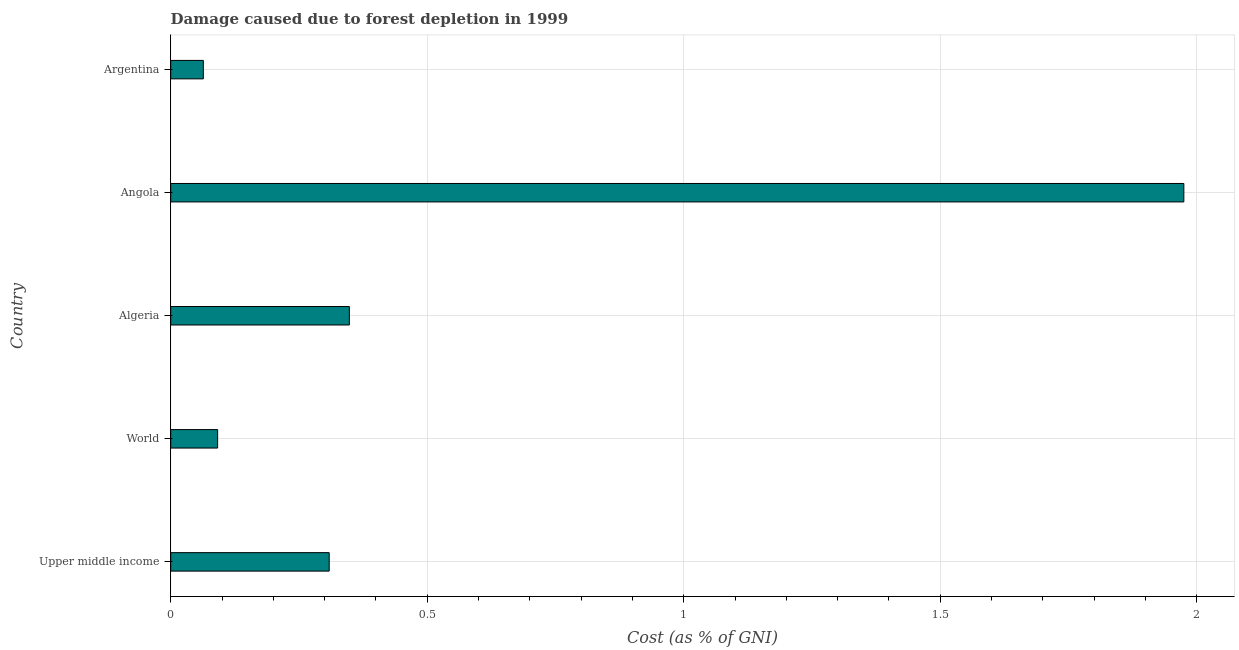Does the graph contain grids?
Provide a succinct answer. Yes. What is the title of the graph?
Your response must be concise. Damage caused due to forest depletion in 1999. What is the label or title of the X-axis?
Your answer should be compact. Cost (as % of GNI). What is the damage caused due to forest depletion in Angola?
Give a very brief answer. 1.97. Across all countries, what is the maximum damage caused due to forest depletion?
Keep it short and to the point. 1.97. Across all countries, what is the minimum damage caused due to forest depletion?
Your answer should be very brief. 0.06. In which country was the damage caused due to forest depletion maximum?
Your answer should be very brief. Angola. In which country was the damage caused due to forest depletion minimum?
Your answer should be compact. Argentina. What is the sum of the damage caused due to forest depletion?
Keep it short and to the point. 2.79. What is the difference between the damage caused due to forest depletion in Argentina and Upper middle income?
Keep it short and to the point. -0.24. What is the average damage caused due to forest depletion per country?
Offer a very short reply. 0.56. What is the median damage caused due to forest depletion?
Your answer should be compact. 0.31. In how many countries, is the damage caused due to forest depletion greater than 0.4 %?
Give a very brief answer. 1. What is the ratio of the damage caused due to forest depletion in Algeria to that in Argentina?
Offer a very short reply. 5.48. What is the difference between the highest and the second highest damage caused due to forest depletion?
Provide a succinct answer. 1.63. Is the sum of the damage caused due to forest depletion in Upper middle income and World greater than the maximum damage caused due to forest depletion across all countries?
Keep it short and to the point. No. What is the difference between the highest and the lowest damage caused due to forest depletion?
Your response must be concise. 1.91. In how many countries, is the damage caused due to forest depletion greater than the average damage caused due to forest depletion taken over all countries?
Your answer should be very brief. 1. How many bars are there?
Ensure brevity in your answer.  5. How many countries are there in the graph?
Ensure brevity in your answer.  5. What is the difference between two consecutive major ticks on the X-axis?
Your response must be concise. 0.5. Are the values on the major ticks of X-axis written in scientific E-notation?
Your answer should be compact. No. What is the Cost (as % of GNI) of Upper middle income?
Ensure brevity in your answer.  0.31. What is the Cost (as % of GNI) in World?
Your answer should be compact. 0.09. What is the Cost (as % of GNI) in Algeria?
Make the answer very short. 0.35. What is the Cost (as % of GNI) in Angola?
Give a very brief answer. 1.97. What is the Cost (as % of GNI) of Argentina?
Offer a terse response. 0.06. What is the difference between the Cost (as % of GNI) in Upper middle income and World?
Your answer should be very brief. 0.22. What is the difference between the Cost (as % of GNI) in Upper middle income and Algeria?
Your response must be concise. -0.04. What is the difference between the Cost (as % of GNI) in Upper middle income and Angola?
Make the answer very short. -1.67. What is the difference between the Cost (as % of GNI) in Upper middle income and Argentina?
Provide a succinct answer. 0.25. What is the difference between the Cost (as % of GNI) in World and Algeria?
Ensure brevity in your answer.  -0.26. What is the difference between the Cost (as % of GNI) in World and Angola?
Your answer should be compact. -1.88. What is the difference between the Cost (as % of GNI) in World and Argentina?
Your answer should be compact. 0.03. What is the difference between the Cost (as % of GNI) in Algeria and Angola?
Offer a very short reply. -1.63. What is the difference between the Cost (as % of GNI) in Algeria and Argentina?
Offer a terse response. 0.28. What is the difference between the Cost (as % of GNI) in Angola and Argentina?
Provide a succinct answer. 1.91. What is the ratio of the Cost (as % of GNI) in Upper middle income to that in World?
Keep it short and to the point. 3.38. What is the ratio of the Cost (as % of GNI) in Upper middle income to that in Algeria?
Provide a succinct answer. 0.89. What is the ratio of the Cost (as % of GNI) in Upper middle income to that in Angola?
Keep it short and to the point. 0.16. What is the ratio of the Cost (as % of GNI) in Upper middle income to that in Argentina?
Offer a very short reply. 4.86. What is the ratio of the Cost (as % of GNI) in World to that in Algeria?
Offer a terse response. 0.26. What is the ratio of the Cost (as % of GNI) in World to that in Angola?
Give a very brief answer. 0.05. What is the ratio of the Cost (as % of GNI) in World to that in Argentina?
Make the answer very short. 1.44. What is the ratio of the Cost (as % of GNI) in Algeria to that in Angola?
Provide a succinct answer. 0.18. What is the ratio of the Cost (as % of GNI) in Algeria to that in Argentina?
Provide a short and direct response. 5.48. What is the ratio of the Cost (as % of GNI) in Angola to that in Argentina?
Provide a short and direct response. 31.07. 